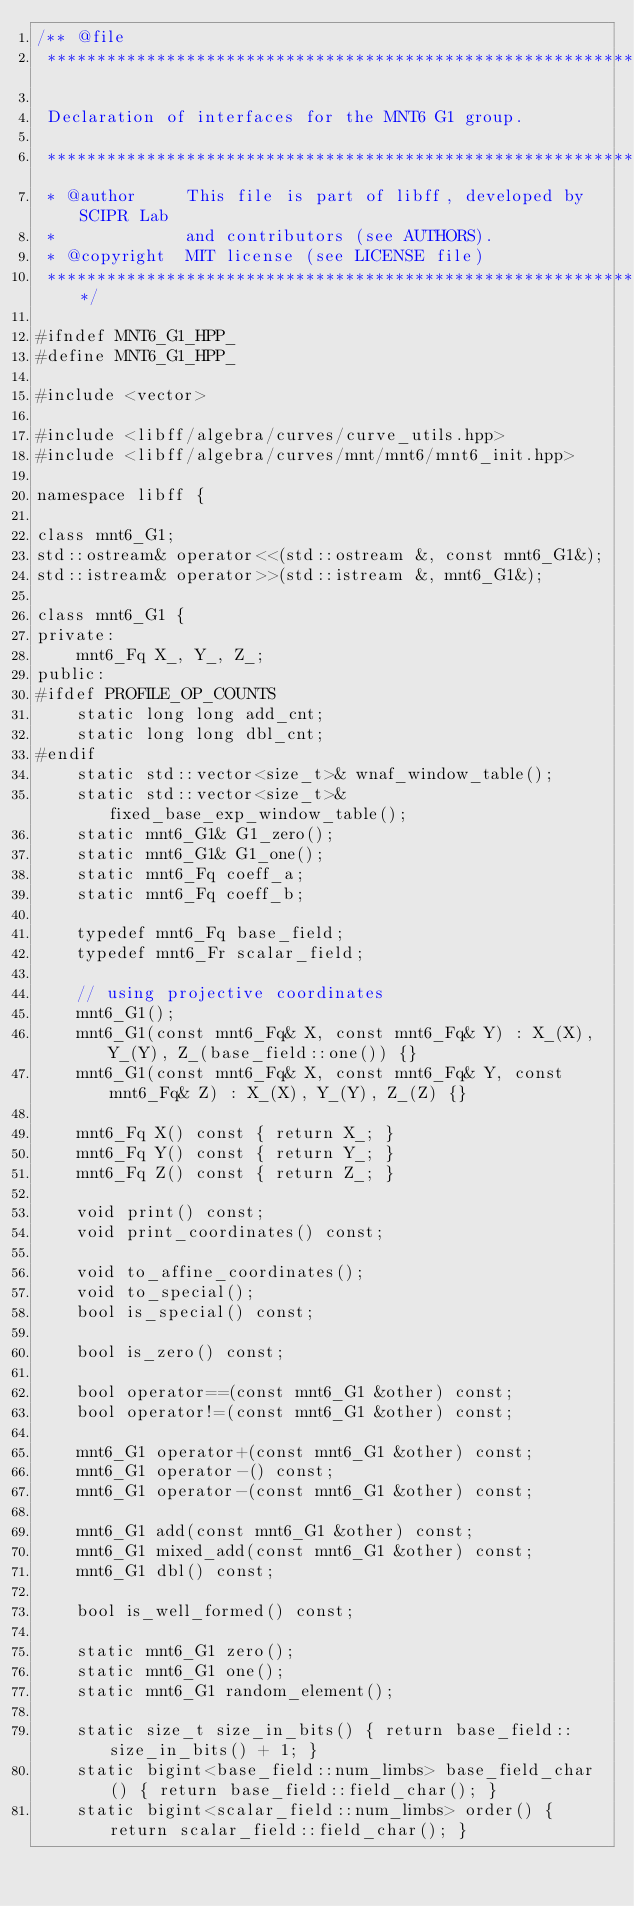Convert code to text. <code><loc_0><loc_0><loc_500><loc_500><_C++_>/** @file
 *****************************************************************************

 Declaration of interfaces for the MNT6 G1 group.

 *****************************************************************************
 * @author     This file is part of libff, developed by SCIPR Lab
 *             and contributors (see AUTHORS).
 * @copyright  MIT license (see LICENSE file)
 *****************************************************************************/

#ifndef MNT6_G1_HPP_
#define MNT6_G1_HPP_

#include <vector>

#include <libff/algebra/curves/curve_utils.hpp>
#include <libff/algebra/curves/mnt/mnt6/mnt6_init.hpp>

namespace libff {

class mnt6_G1;
std::ostream& operator<<(std::ostream &, const mnt6_G1&);
std::istream& operator>>(std::istream &, mnt6_G1&);

class mnt6_G1 {
private:
    mnt6_Fq X_, Y_, Z_;
public:
#ifdef PROFILE_OP_COUNTS
    static long long add_cnt;
    static long long dbl_cnt;
#endif
    static std::vector<size_t>& wnaf_window_table();
    static std::vector<size_t>& fixed_base_exp_window_table();
    static mnt6_G1& G1_zero();
    static mnt6_G1& G1_one();
    static mnt6_Fq coeff_a;
    static mnt6_Fq coeff_b;

    typedef mnt6_Fq base_field;
    typedef mnt6_Fr scalar_field;

    // using projective coordinates
    mnt6_G1();
    mnt6_G1(const mnt6_Fq& X, const mnt6_Fq& Y) : X_(X), Y_(Y), Z_(base_field::one()) {}
    mnt6_G1(const mnt6_Fq& X, const mnt6_Fq& Y, const mnt6_Fq& Z) : X_(X), Y_(Y), Z_(Z) {}

    mnt6_Fq X() const { return X_; }
    mnt6_Fq Y() const { return Y_; }
    mnt6_Fq Z() const { return Z_; }

    void print() const;
    void print_coordinates() const;

    void to_affine_coordinates();
    void to_special();
    bool is_special() const;

    bool is_zero() const;

    bool operator==(const mnt6_G1 &other) const;
    bool operator!=(const mnt6_G1 &other) const;

    mnt6_G1 operator+(const mnt6_G1 &other) const;
    mnt6_G1 operator-() const;
    mnt6_G1 operator-(const mnt6_G1 &other) const;

    mnt6_G1 add(const mnt6_G1 &other) const;
    mnt6_G1 mixed_add(const mnt6_G1 &other) const;
    mnt6_G1 dbl() const;

    bool is_well_formed() const;

    static mnt6_G1 zero();
    static mnt6_G1 one();
    static mnt6_G1 random_element();

    static size_t size_in_bits() { return base_field::size_in_bits() + 1; }
    static bigint<base_field::num_limbs> base_field_char() { return base_field::field_char(); }
    static bigint<scalar_field::num_limbs> order() { return scalar_field::field_char(); }
</code> 